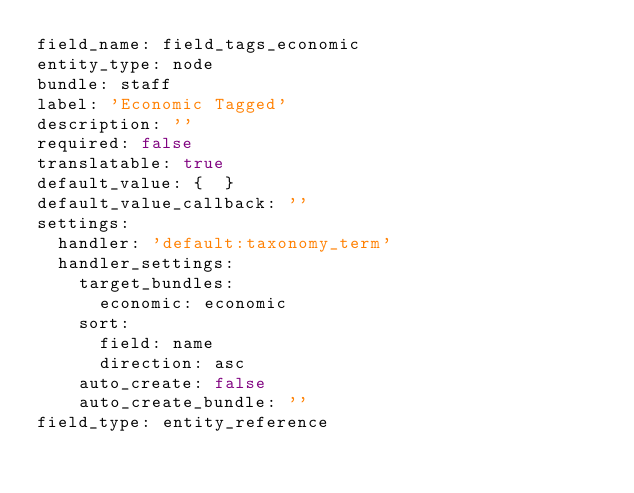<code> <loc_0><loc_0><loc_500><loc_500><_YAML_>field_name: field_tags_economic
entity_type: node
bundle: staff
label: 'Economic Tagged'
description: ''
required: false
translatable: true
default_value: {  }
default_value_callback: ''
settings:
  handler: 'default:taxonomy_term'
  handler_settings:
    target_bundles:
      economic: economic
    sort:
      field: name
      direction: asc
    auto_create: false
    auto_create_bundle: ''
field_type: entity_reference
</code> 